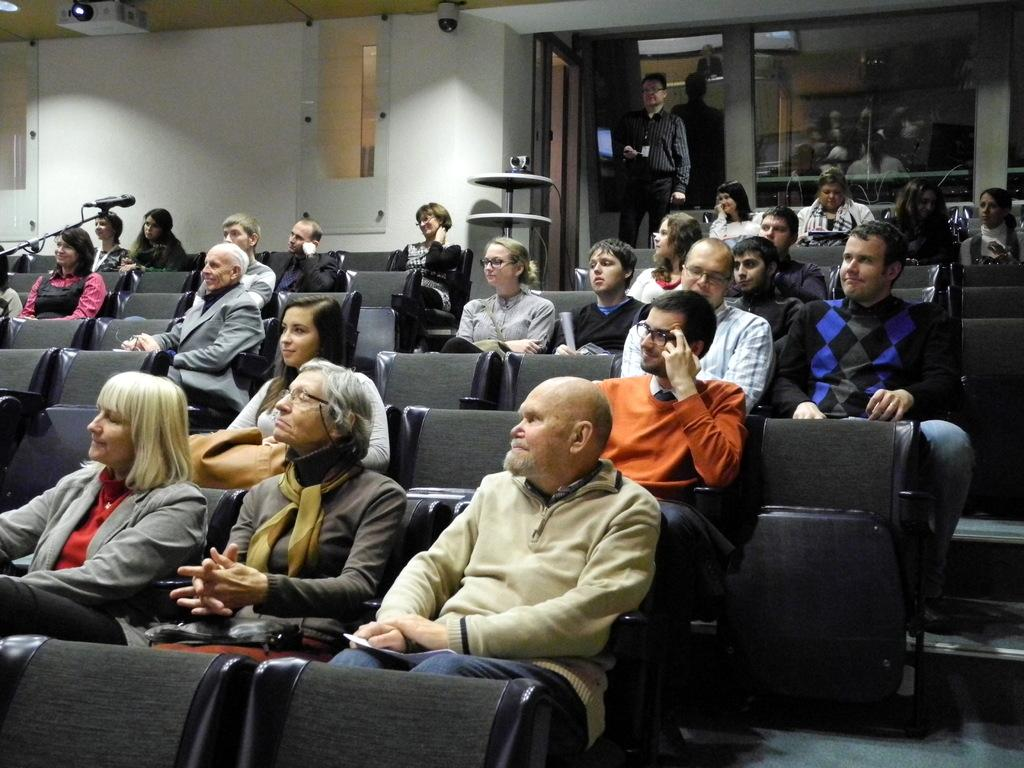How many people are in the image? There is a group of people in the image. What are the people doing in the image? The people are sitting on chairs, and one person is standing. What can be seen in the background of the image? There is a microphone and a wall in the background, along with other objects. What type of produce is being harvested in the garden in the image? There is no garden or produce present in the image. What ingredients are used to make the stew in the image? There is no stew present in the image. 